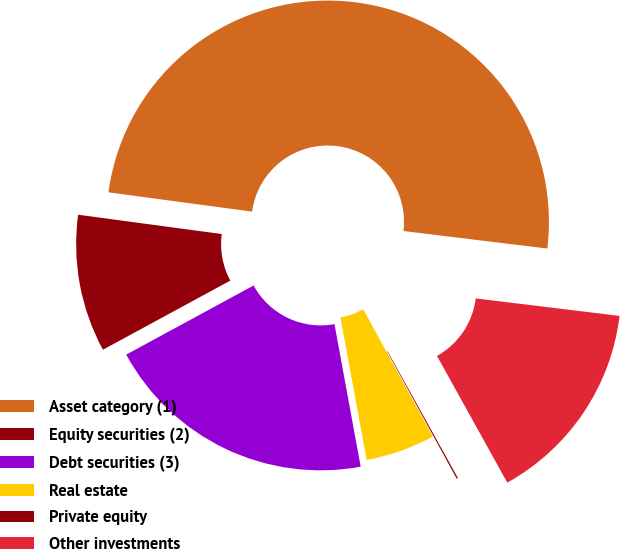Convert chart. <chart><loc_0><loc_0><loc_500><loc_500><pie_chart><fcel>Asset category (1)<fcel>Equity securities (2)<fcel>Debt securities (3)<fcel>Real estate<fcel>Private equity<fcel>Other investments<nl><fcel>49.8%<fcel>10.04%<fcel>19.98%<fcel>5.07%<fcel>0.1%<fcel>15.01%<nl></chart> 